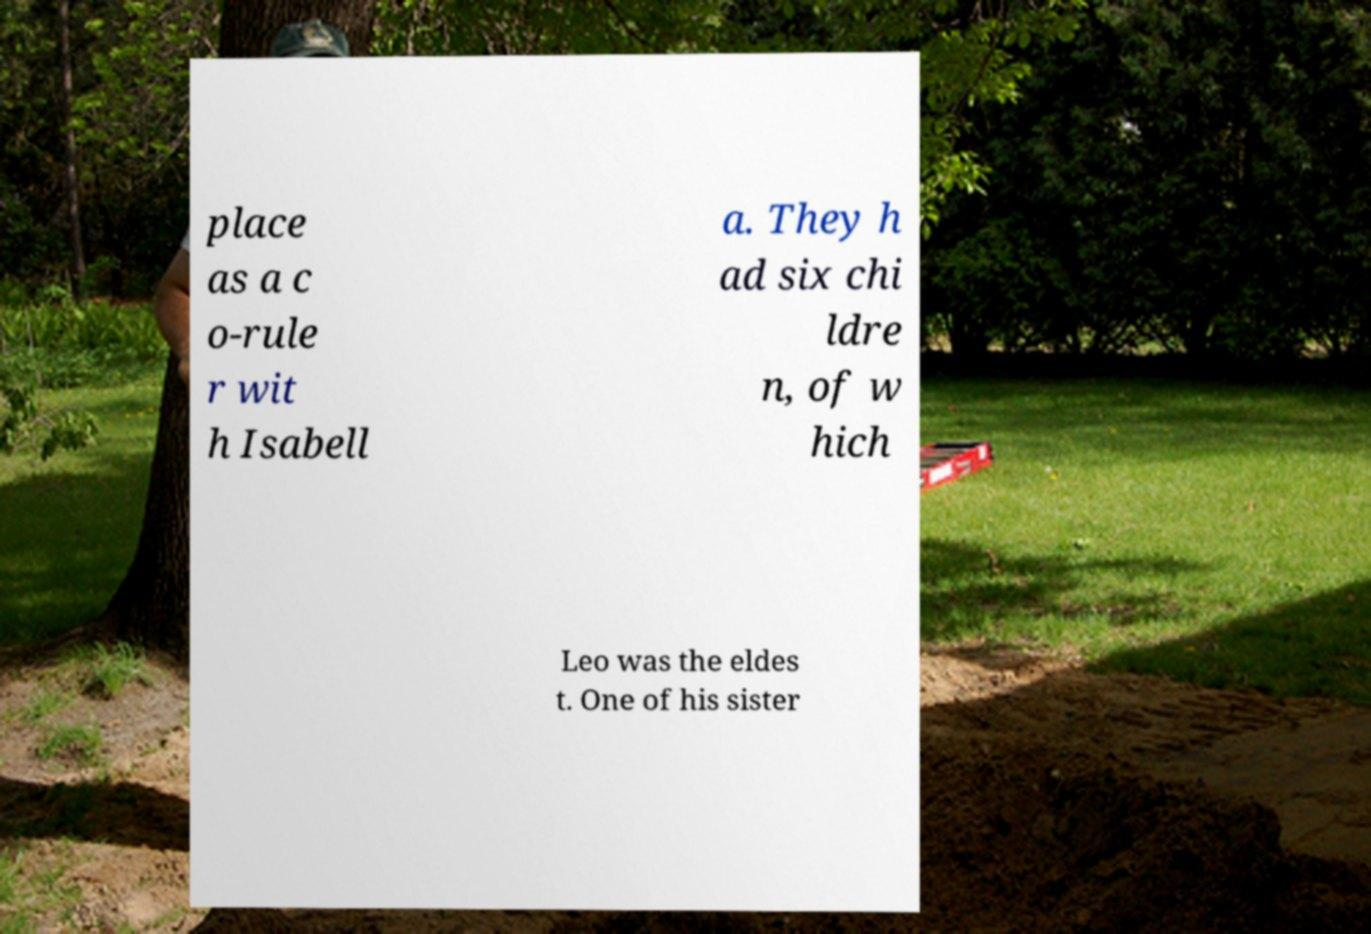What messages or text are displayed in this image? I need them in a readable, typed format. place as a c o-rule r wit h Isabell a. They h ad six chi ldre n, of w hich Leo was the eldes t. One of his sister 